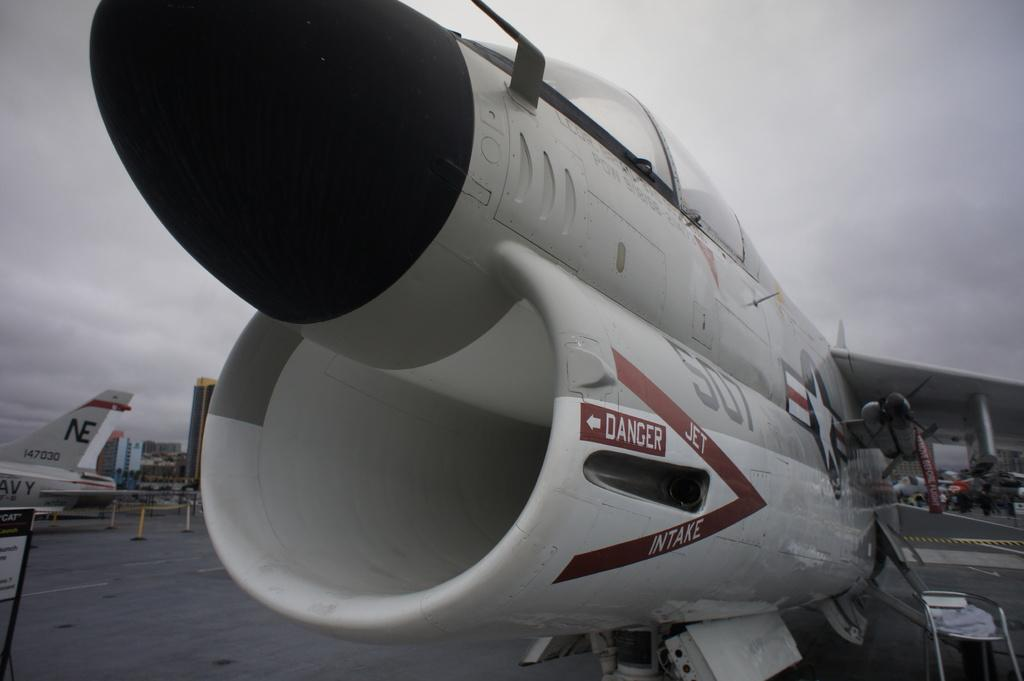Provide a one-sentence caption for the provided image. A jet engine with a danger warning on the side. 